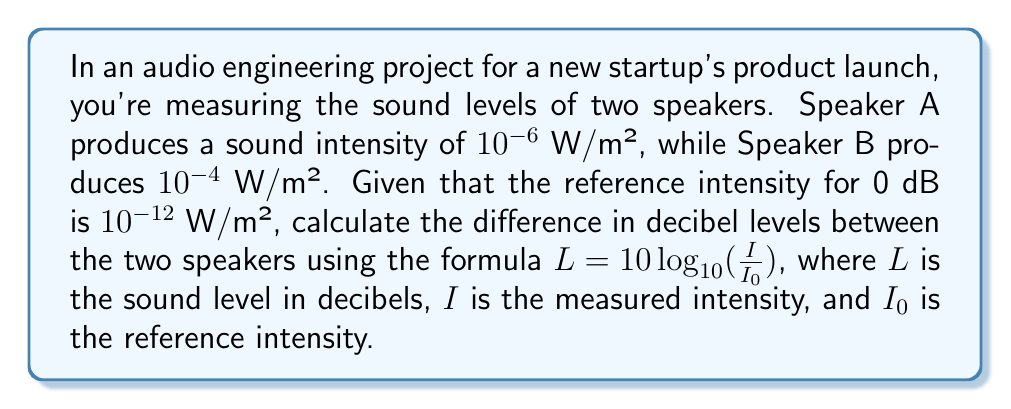Give your solution to this math problem. Let's approach this step-by-step:

1) First, calculate the decibel level for Speaker A:
   $L_A = 10 \log_{10}(\frac{I_A}{I_0})$
   $L_A = 10 \log_{10}(\frac{10^{-6}}{10^{-12}})$
   $L_A = 10 \log_{10}(10^6) = 10 \cdot 6 = 60$ dB

2) Now, calculate the decibel level for Speaker B:
   $L_B = 10 \log_{10}(\frac{I_B}{I_0})$
   $L_B = 10 \log_{10}(\frac{10^{-4}}{10^{-12}})$
   $L_B = 10 \log_{10}(10^8) = 10 \cdot 8 = 80$ dB

3) To find the difference, subtract the decibel level of Speaker A from Speaker B:
   Difference = $L_B - L_A = 80 - 60 = 20$ dB

This result shows that Speaker B is 20 dB louder than Speaker A, which is a significant difference in perceived loudness.
Answer: 20 dB 